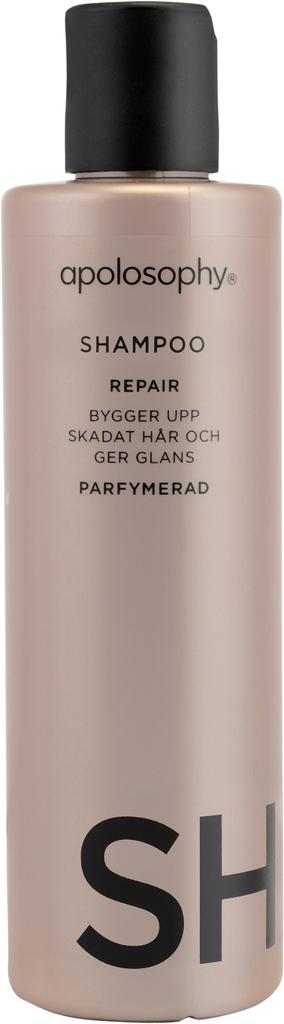What type of bottle is this?
Your response must be concise. Shampoo. What type of shampoo is it?
Your answer should be very brief. Repair. 